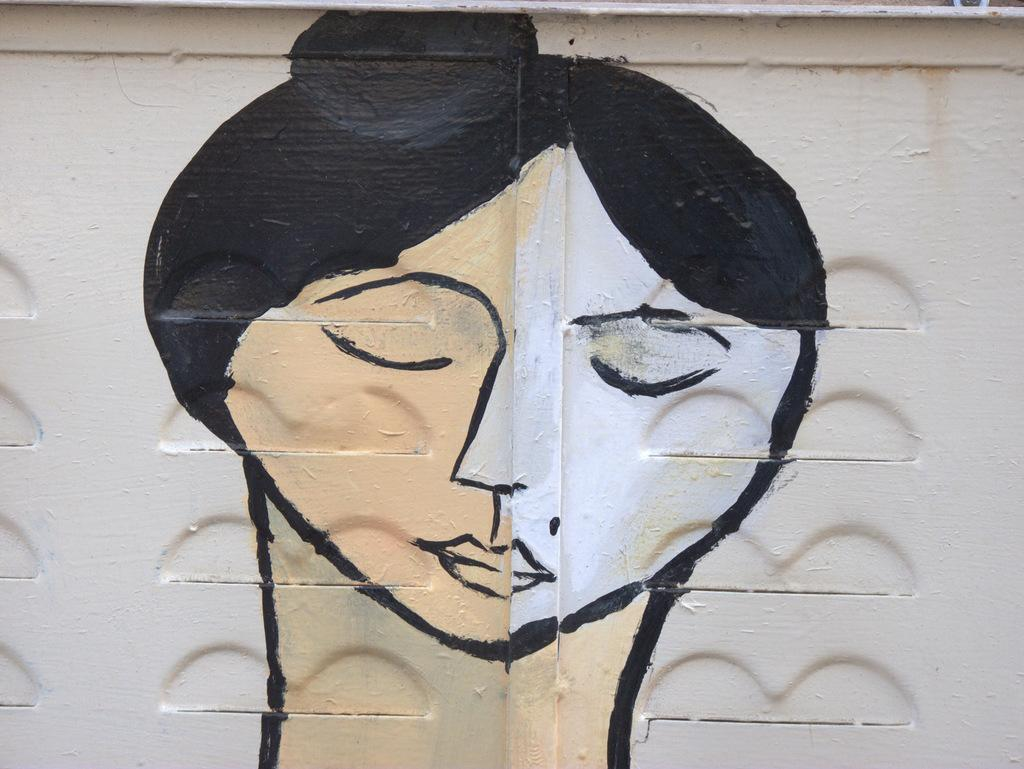What is depicted in the image? There is a painting in the image. What is the subject of the painting? The painting is of a woman. Where is the painting located? The painting is on a wall. What type of chalk is being used to create the painting in the image? There is no chalk present in the image; the painting is already complete. How does the painting cause destruction in the image? The painting does not cause destruction in the image; it is a static piece of art on a wall. 